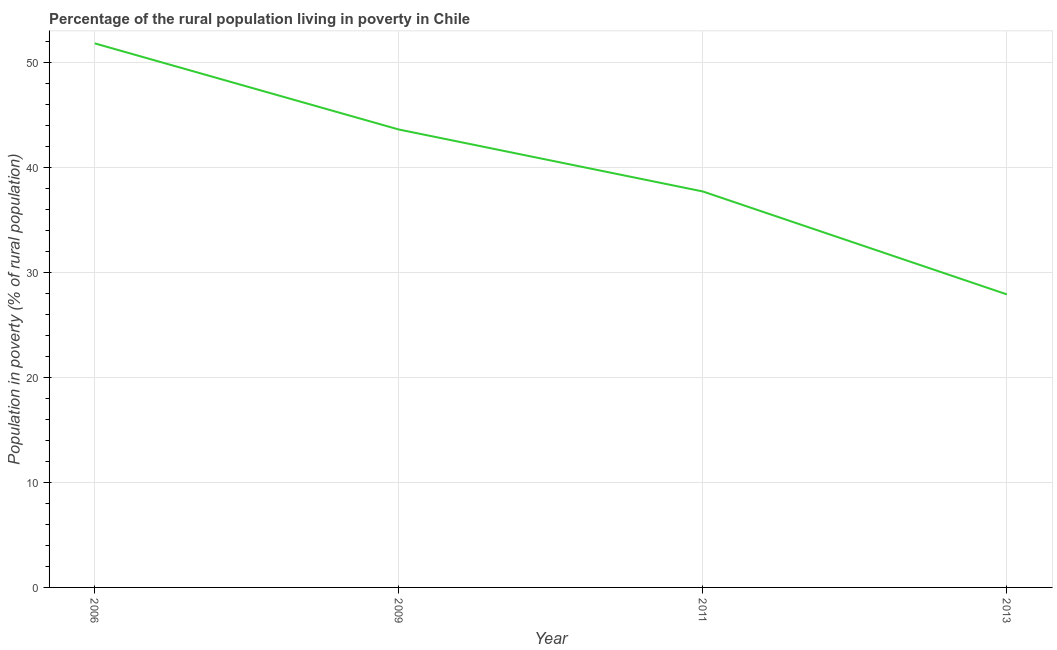What is the percentage of rural population living below poverty line in 2011?
Keep it short and to the point. 37.7. Across all years, what is the maximum percentage of rural population living below poverty line?
Your response must be concise. 51.8. Across all years, what is the minimum percentage of rural population living below poverty line?
Make the answer very short. 27.9. In which year was the percentage of rural population living below poverty line minimum?
Make the answer very short. 2013. What is the sum of the percentage of rural population living below poverty line?
Provide a succinct answer. 161. What is the difference between the percentage of rural population living below poverty line in 2006 and 2009?
Provide a short and direct response. 8.2. What is the average percentage of rural population living below poverty line per year?
Ensure brevity in your answer.  40.25. What is the median percentage of rural population living below poverty line?
Offer a terse response. 40.65. Do a majority of the years between 2009 and 2011 (inclusive) have percentage of rural population living below poverty line greater than 20 %?
Keep it short and to the point. Yes. What is the ratio of the percentage of rural population living below poverty line in 2009 to that in 2013?
Your answer should be compact. 1.56. What is the difference between the highest and the second highest percentage of rural population living below poverty line?
Offer a very short reply. 8.2. What is the difference between the highest and the lowest percentage of rural population living below poverty line?
Provide a short and direct response. 23.9. In how many years, is the percentage of rural population living below poverty line greater than the average percentage of rural population living below poverty line taken over all years?
Offer a very short reply. 2. Does the percentage of rural population living below poverty line monotonically increase over the years?
Your answer should be compact. No. Does the graph contain any zero values?
Ensure brevity in your answer.  No. Does the graph contain grids?
Your response must be concise. Yes. What is the title of the graph?
Your answer should be compact. Percentage of the rural population living in poverty in Chile. What is the label or title of the Y-axis?
Provide a short and direct response. Population in poverty (% of rural population). What is the Population in poverty (% of rural population) in 2006?
Provide a short and direct response. 51.8. What is the Population in poverty (% of rural population) in 2009?
Your answer should be very brief. 43.6. What is the Population in poverty (% of rural population) in 2011?
Provide a succinct answer. 37.7. What is the Population in poverty (% of rural population) in 2013?
Give a very brief answer. 27.9. What is the difference between the Population in poverty (% of rural population) in 2006 and 2009?
Provide a succinct answer. 8.2. What is the difference between the Population in poverty (% of rural population) in 2006 and 2011?
Your response must be concise. 14.1. What is the difference between the Population in poverty (% of rural population) in 2006 and 2013?
Offer a terse response. 23.9. What is the ratio of the Population in poverty (% of rural population) in 2006 to that in 2009?
Offer a very short reply. 1.19. What is the ratio of the Population in poverty (% of rural population) in 2006 to that in 2011?
Your answer should be very brief. 1.37. What is the ratio of the Population in poverty (% of rural population) in 2006 to that in 2013?
Offer a very short reply. 1.86. What is the ratio of the Population in poverty (% of rural population) in 2009 to that in 2011?
Give a very brief answer. 1.16. What is the ratio of the Population in poverty (% of rural population) in 2009 to that in 2013?
Give a very brief answer. 1.56. What is the ratio of the Population in poverty (% of rural population) in 2011 to that in 2013?
Your answer should be compact. 1.35. 